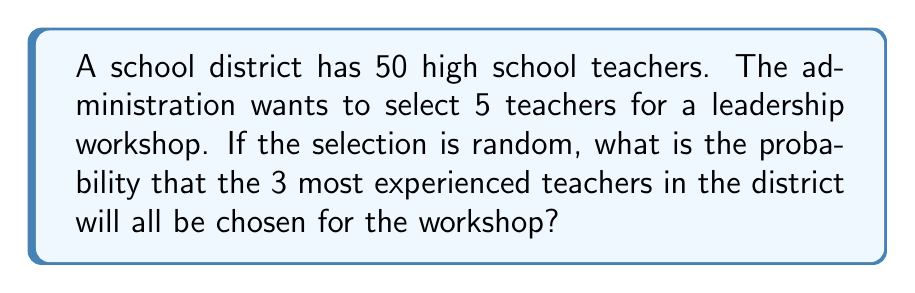Give your solution to this math problem. Let's approach this step-by-step:

1) First, we need to calculate the total number of ways to select 5 teachers from 50. This is a combination problem, denoted as $\binom{50}{5}$ or $C(50,5)$.

   $$\binom{50}{5} = \frac{50!}{5!(50-5)!} = \frac{50!}{5!45!}$$

2) Next, we need to consider that we want the 3 most experienced teachers to be included. So, we need to select these 3 plus 2 more from the remaining 47 teachers.

3) The number of ways to select 2 teachers from 47 is $\binom{47}{2}$.

   $$\binom{47}{2} = \frac{47!}{2!(47-2)!} = \frac{47!}{2!45!}$$

4) The probability is then the number of favorable outcomes divided by the total number of possible outcomes:

   $$P(\text{3 most experienced chosen}) = \frac{\binom{47}{2}}{\binom{50}{5}}$$

5) Let's calculate this:

   $$\frac{\binom{47}{2}}{\binom{50}{5}} = \frac{47!}{2!45!} \cdot \frac{5!45!}{50!}$$

6) The 45! cancels out in the numerator and denominator:

   $$= \frac{47 \cdot 46 \cdot 5!}{50 \cdot 49 \cdot 48 \cdot 47 \cdot 46}$$

7) Simplifying:

   $$= \frac{47 \cdot 46 \cdot 5 \cdot 4 \cdot 3 \cdot 2 \cdot 1}{50 \cdot 49 \cdot 48 \cdot 47 \cdot 46} = \frac{120}{19600} = \frac{3}{490} \approx 0.00612$$
Answer: $\frac{3}{490}$ or approximately 0.00612 